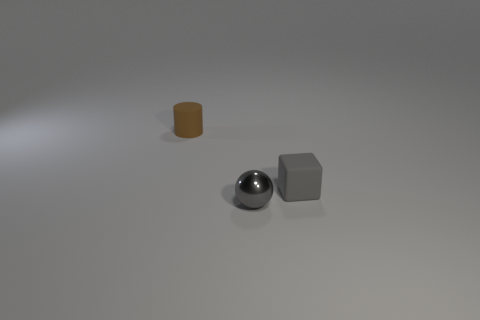There is a gray object that is made of the same material as the small cylinder; what size is it?
Make the answer very short. Small. There is a gray object that is to the left of the tiny rubber thing that is to the right of the brown cylinder; what number of gray rubber objects are to the left of it?
Provide a succinct answer. 0. Does the metallic object have the same shape as the tiny gray matte object?
Your answer should be compact. No. Is the material of the object that is behind the small gray cube the same as the small gray thing that is behind the gray ball?
Provide a succinct answer. Yes. How many objects are matte cylinders behind the metallic sphere or matte objects that are on the left side of the small gray ball?
Your response must be concise. 1. Is there anything else that is the same shape as the brown object?
Offer a terse response. No. How many cyan shiny balls are there?
Ensure brevity in your answer.  0. Is there a ball that has the same size as the gray matte object?
Provide a succinct answer. Yes. Is the material of the brown cylinder the same as the object in front of the gray rubber block?
Your answer should be compact. No. There is a gray object in front of the gray matte cube; what is its material?
Provide a short and direct response. Metal. 